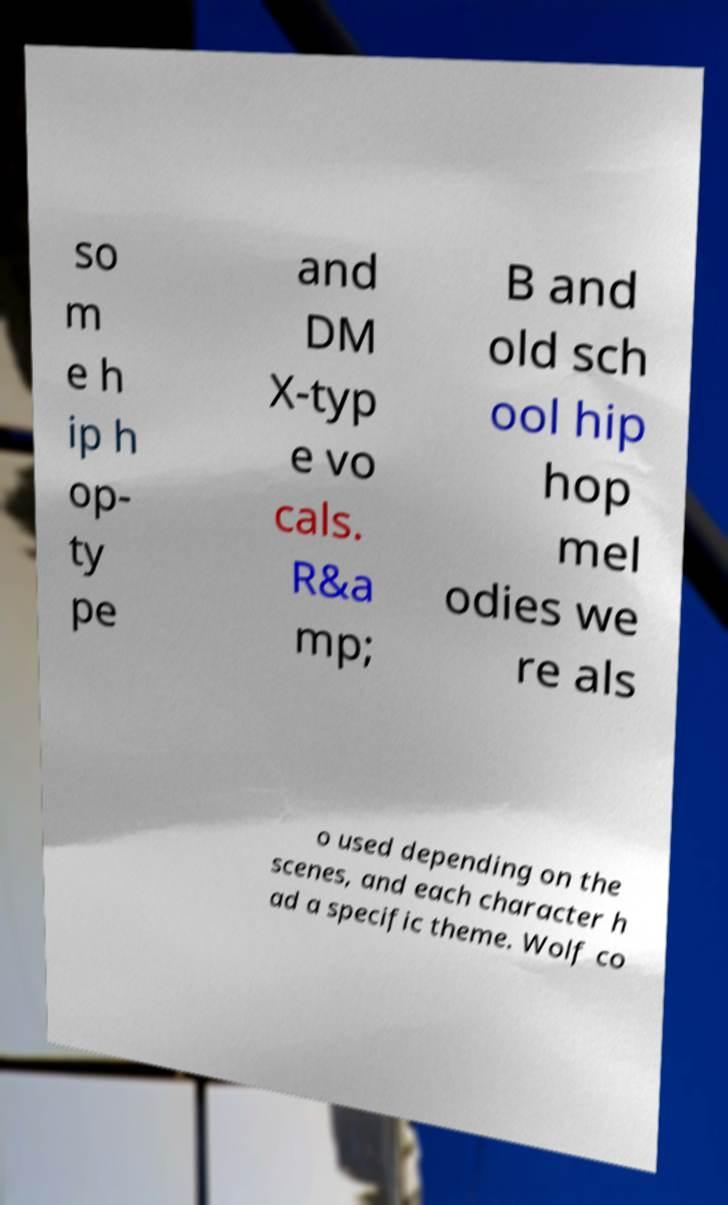Can you read and provide the text displayed in the image?This photo seems to have some interesting text. Can you extract and type it out for me? so m e h ip h op- ty pe and DM X-typ e vo cals. R&a mp; B and old sch ool hip hop mel odies we re als o used depending on the scenes, and each character h ad a specific theme. Wolf co 